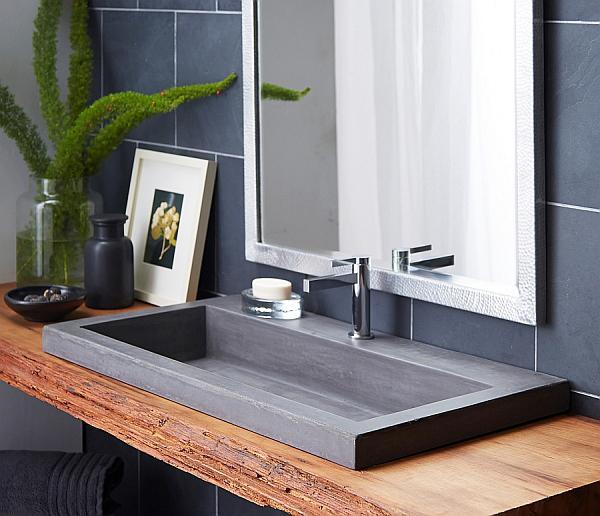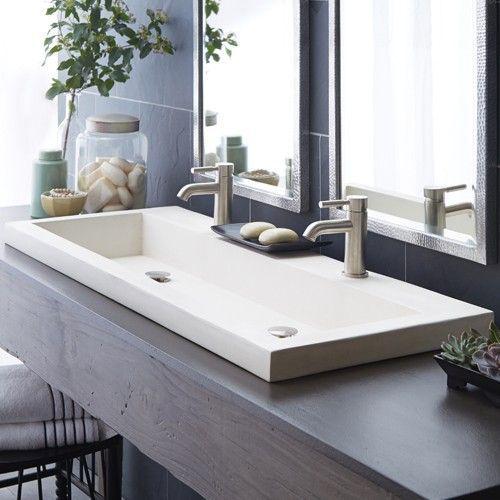The first image is the image on the left, the second image is the image on the right. Considering the images on both sides, is "A jar of fernlike foliage and a leaning framed picture are next to a rectangular gray sink mounted on a wood plank." valid? Answer yes or no. Yes. The first image is the image on the left, the second image is the image on the right. Assess this claim about the two images: "The sink in one of the images is set into a brown wood hanging counter.". Correct or not? Answer yes or no. Yes. 